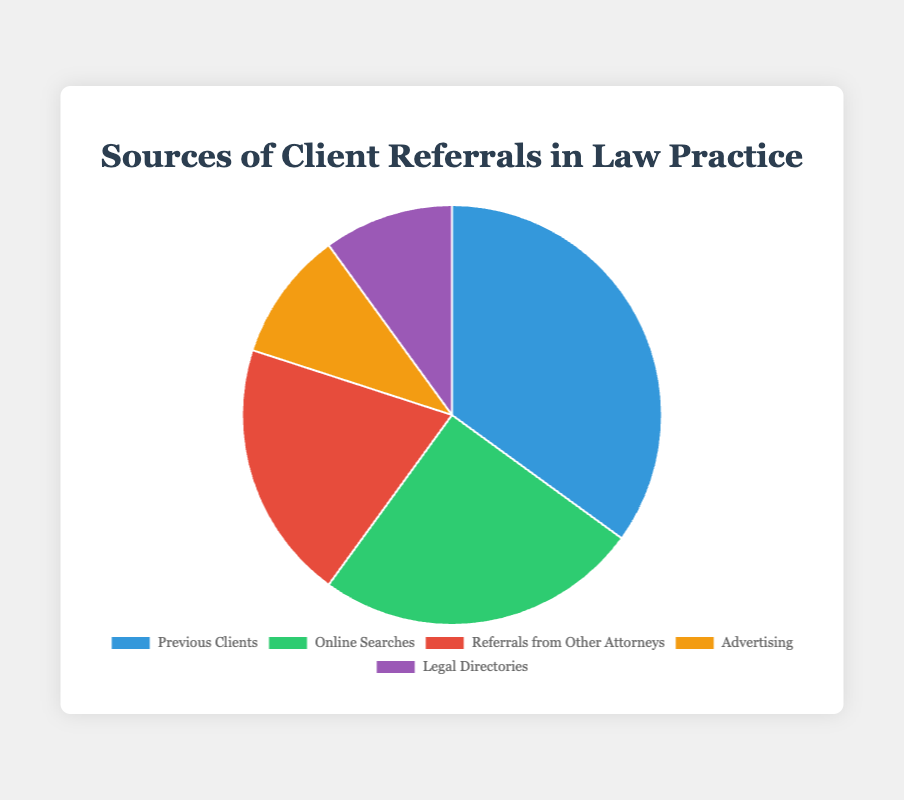What percentage of client referrals come from previous clients? Referring to the pie chart, the segment representing "Previous Clients" is labeled with a percentage value.
Answer: 35% How much larger is the percentage of referrals from previous clients compared to advertising? Subtract the percentage of "Advertising" (10%) from the percentage of "Previous Clients" (35%). 35% - 10% = 25%
Answer: 25% Which two sources contribute equally to client referrals? Look at the pie chart to find segments with the same percentage value. The "Advertising" and "Legal Directories" sections both contribute 10% of referrals.
Answer: Advertising and Legal Directories What is the total percentage of client referrals from online searches and referrals from other attorneys combined? Add the percentage of "Online Searches" (25%) to the percentage of "Referrals from Other Attorneys" (20%). 25% + 20% = 45%
Answer: 45% Which source has the second largest share of client referrals? Excluding the largest segment ("Previous Clients" at 35%), the next largest segment is "Online Searches" with 25%.
Answer: Online Searches What is the difference in percentage between the highest and lowest sources of client referrals? Identify the highest percentage ("Previous Clients" at 35%) and the lowest (both "Advertising" and "Legal Directories" at 10%). Subtract the lowest from the highest. 35% - 10% = 25%
Answer: 25% How many sources contribute to at least 20% of client referrals each? Check the pie chart to identify sources with 20% or more. "Previous Clients" (35%), "Online Searches" (25%), and "Referrals from Other Attorneys" (20%) meet this criterion.
Answer: 3 Which source represented by a green section and what percentage does it contribute? The pie chart shows that the green section corresponds to "Online Searches."
Answer: 25% What combined percentage is contributed by sources with less than 20% each? Add "Advertising" (10%) and "Legal Directories" (10%) because they each contribute less than 20%. 10% + 10% = 20%
Answer: 20% Which source referred by another attorney and what percentage does it contribute? The pie chart shows that "Referrals from Other Attorneys" contributes 20%.
Answer: 20% 